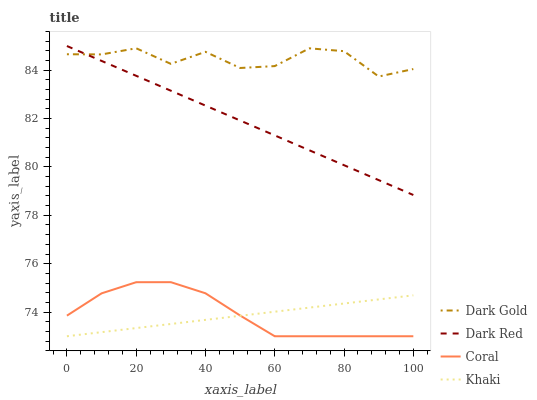Does Khaki have the minimum area under the curve?
Answer yes or no. Yes. Does Dark Gold have the maximum area under the curve?
Answer yes or no. Yes. Does Coral have the minimum area under the curve?
Answer yes or no. No. Does Coral have the maximum area under the curve?
Answer yes or no. No. Is Dark Red the smoothest?
Answer yes or no. Yes. Is Dark Gold the roughest?
Answer yes or no. Yes. Is Coral the smoothest?
Answer yes or no. No. Is Coral the roughest?
Answer yes or no. No. Does Coral have the lowest value?
Answer yes or no. Yes. Does Dark Gold have the lowest value?
Answer yes or no. No. Does Dark Red have the highest value?
Answer yes or no. Yes. Does Coral have the highest value?
Answer yes or no. No. Is Coral less than Dark Gold?
Answer yes or no. Yes. Is Dark Gold greater than Coral?
Answer yes or no. Yes. Does Khaki intersect Coral?
Answer yes or no. Yes. Is Khaki less than Coral?
Answer yes or no. No. Is Khaki greater than Coral?
Answer yes or no. No. Does Coral intersect Dark Gold?
Answer yes or no. No. 